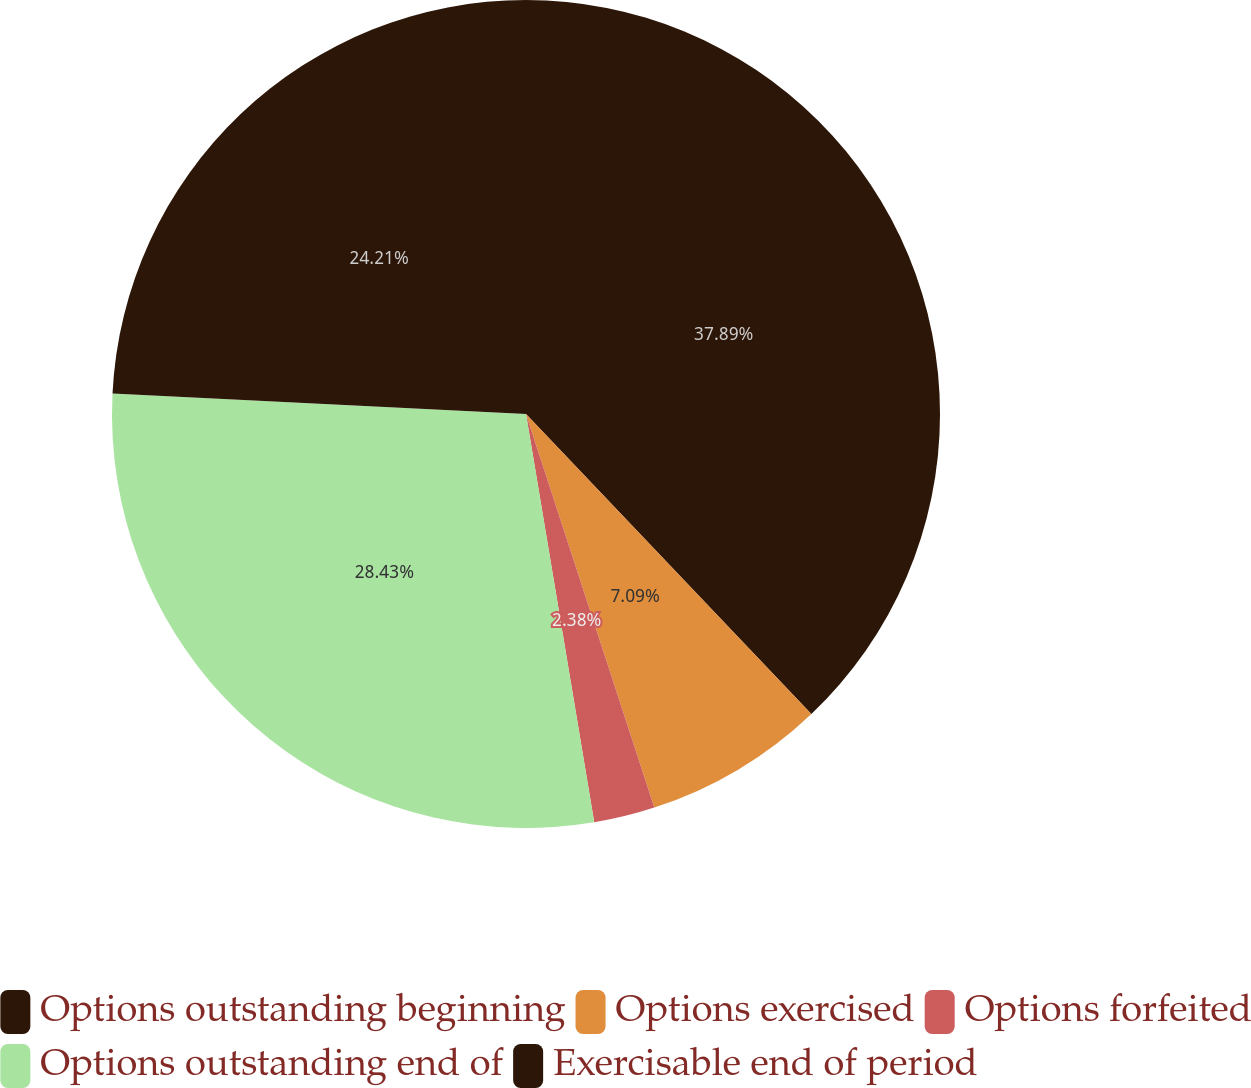<chart> <loc_0><loc_0><loc_500><loc_500><pie_chart><fcel>Options outstanding beginning<fcel>Options exercised<fcel>Options forfeited<fcel>Options outstanding end of<fcel>Exercisable end of period<nl><fcel>37.9%<fcel>7.09%<fcel>2.38%<fcel>28.43%<fcel>24.21%<nl></chart> 